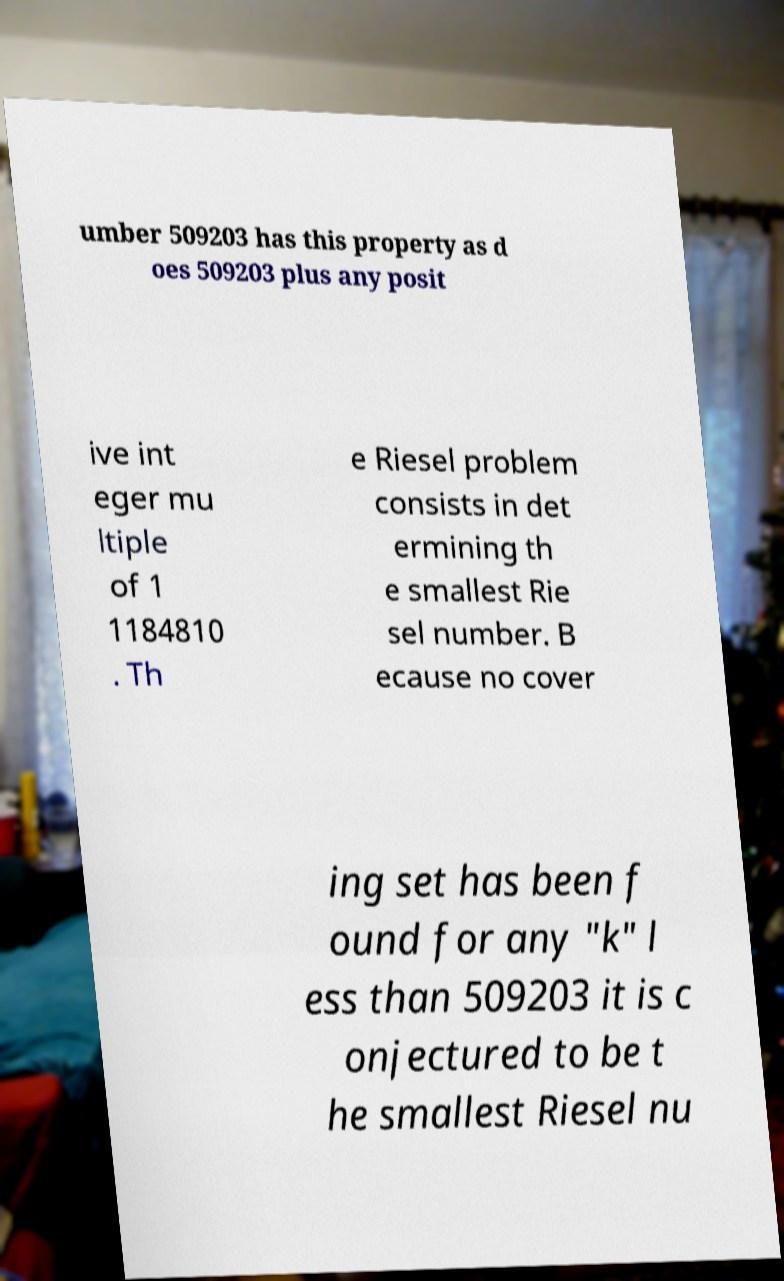There's text embedded in this image that I need extracted. Can you transcribe it verbatim? umber 509203 has this property as d oes 509203 plus any posit ive int eger mu ltiple of 1 1184810 . Th e Riesel problem consists in det ermining th e smallest Rie sel number. B ecause no cover ing set has been f ound for any "k" l ess than 509203 it is c onjectured to be t he smallest Riesel nu 